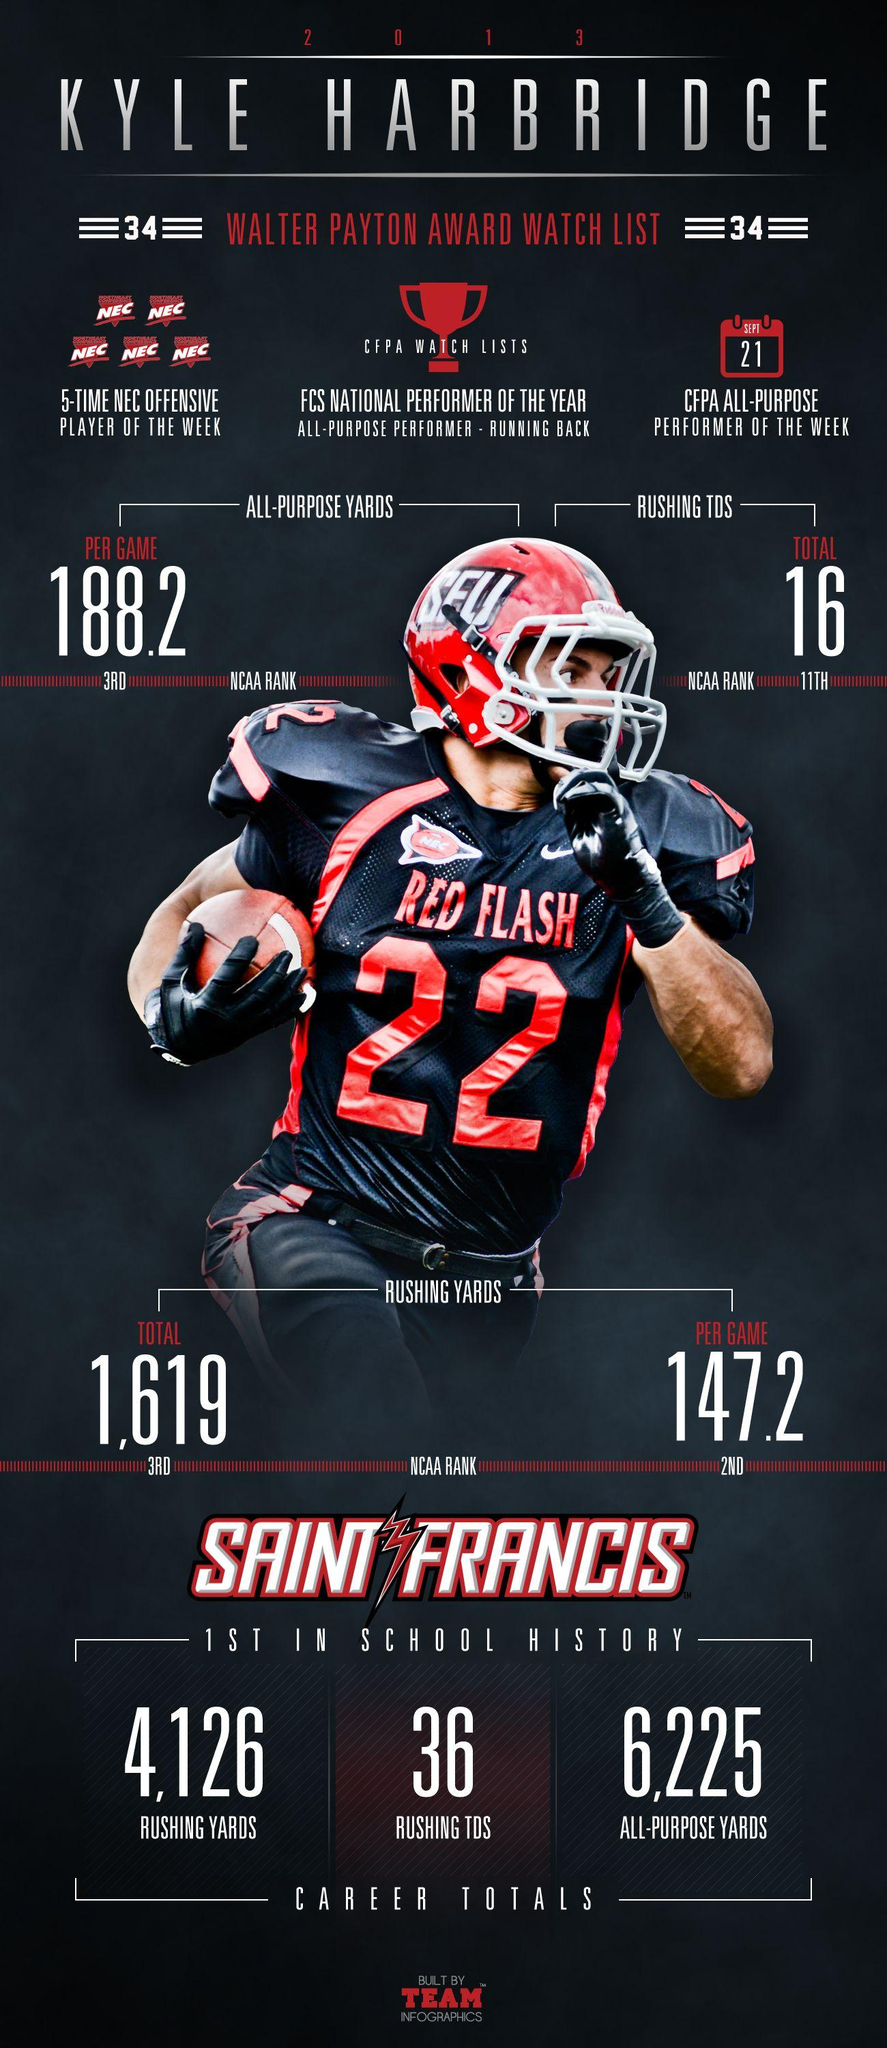Identify some key points in this picture. Kyle Harbridge has rushing yards per game of 147.2. Kyle Harbridge has rushed for a total of 1,619 yards. In total, Kyle Harbridge has rushed for 16 touchdowns. Kyle Harbridge has an impressive all-purpose yards per game average of 188.2. 